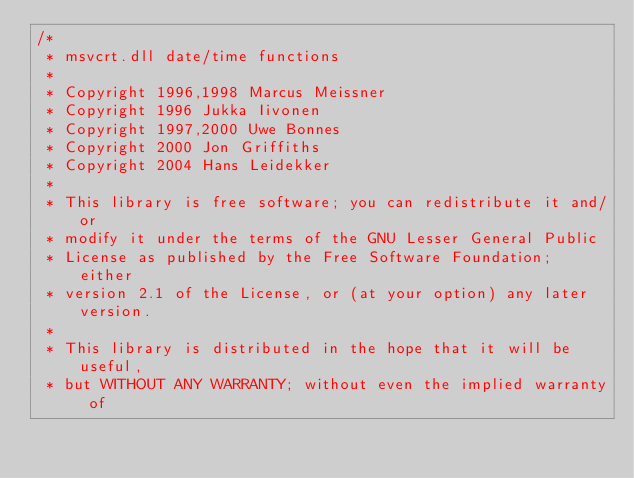<code> <loc_0><loc_0><loc_500><loc_500><_C_>/*
 * msvcrt.dll date/time functions
 *
 * Copyright 1996,1998 Marcus Meissner
 * Copyright 1996 Jukka Iivonen
 * Copyright 1997,2000 Uwe Bonnes
 * Copyright 2000 Jon Griffiths
 * Copyright 2004 Hans Leidekker
 *
 * This library is free software; you can redistribute it and/or
 * modify it under the terms of the GNU Lesser General Public
 * License as published by the Free Software Foundation; either
 * version 2.1 of the License, or (at your option) any later version.
 *
 * This library is distributed in the hope that it will be useful,
 * but WITHOUT ANY WARRANTY; without even the implied warranty of</code> 